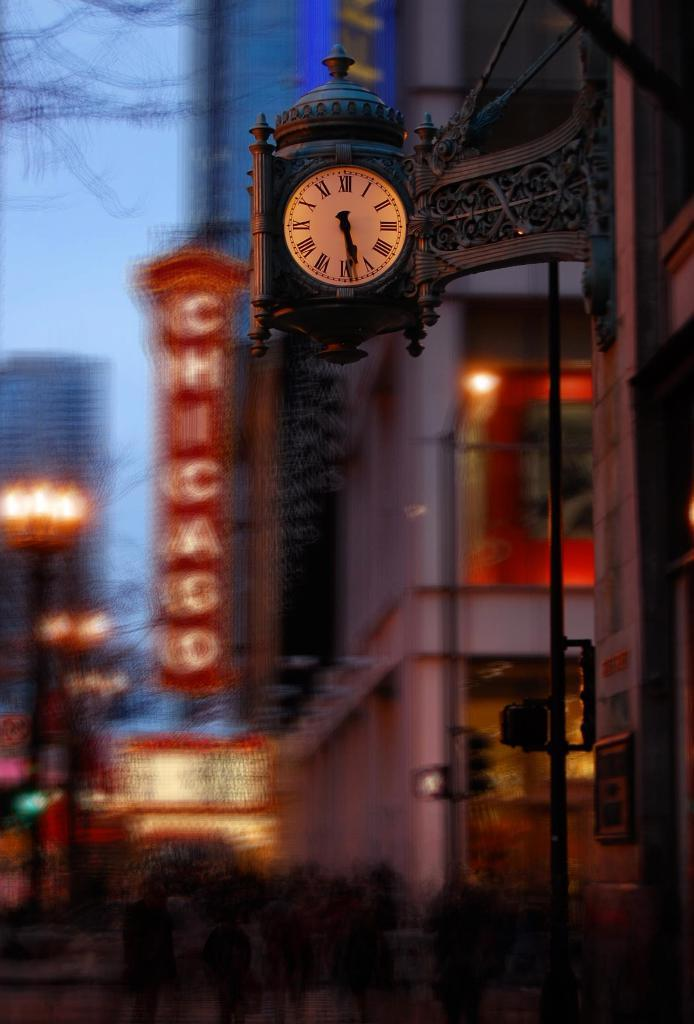Provide a one-sentence caption for the provided image. A street view of a busy downtown area with people walking along the rows of stores in Chicago. 